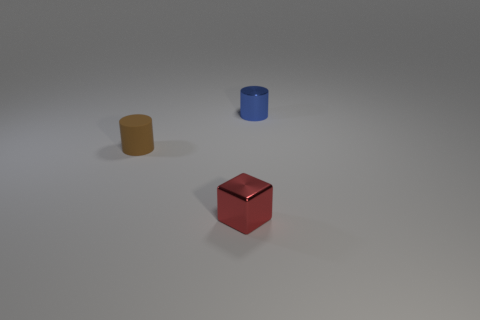Add 1 rubber things. How many objects exist? 4 Subtract all blocks. How many objects are left? 2 Subtract all tiny red shiny objects. Subtract all large purple rubber balls. How many objects are left? 2 Add 1 tiny brown rubber cylinders. How many tiny brown rubber cylinders are left? 2 Add 2 small objects. How many small objects exist? 5 Subtract 0 red cylinders. How many objects are left? 3 